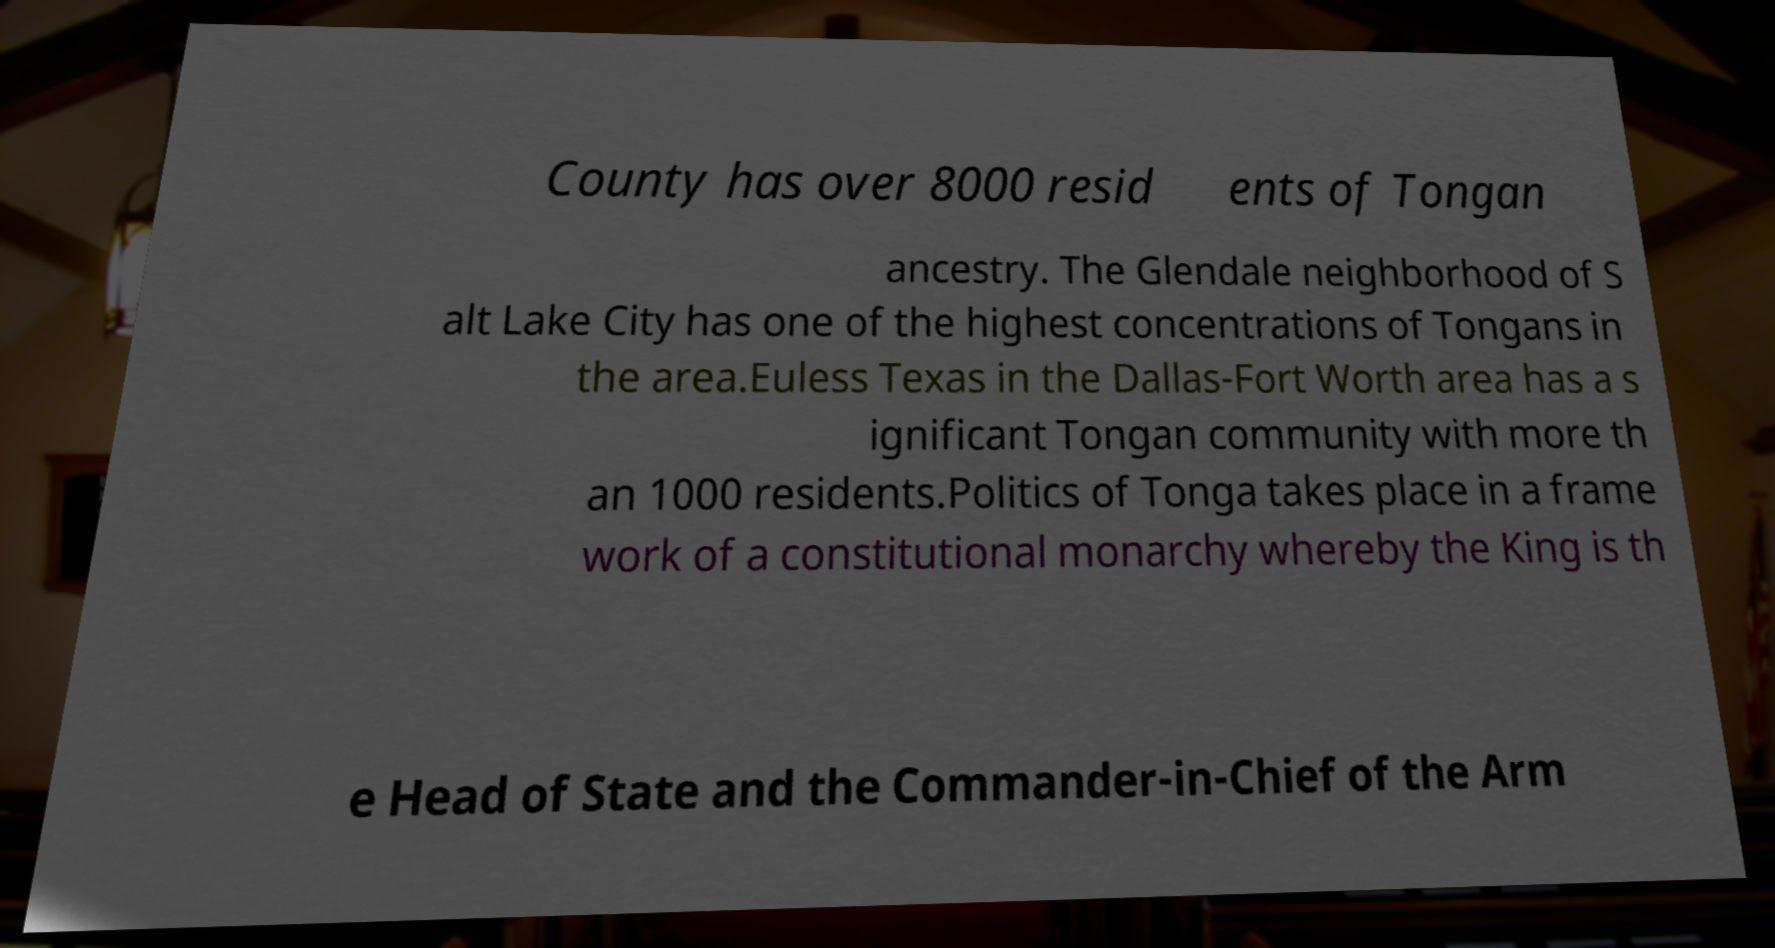Could you extract and type out the text from this image? County has over 8000 resid ents of Tongan ancestry. The Glendale neighborhood of S alt Lake City has one of the highest concentrations of Tongans in the area.Euless Texas in the Dallas-Fort Worth area has a s ignificant Tongan community with more th an 1000 residents.Politics of Tonga takes place in a frame work of a constitutional monarchy whereby the King is th e Head of State and the Commander-in-Chief of the Arm 